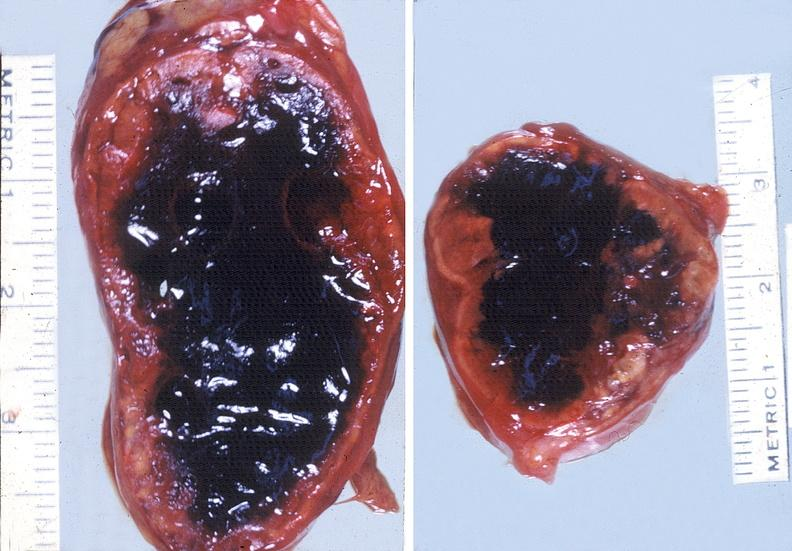where does this belong to?
Answer the question using a single word or phrase. Endocrine system 